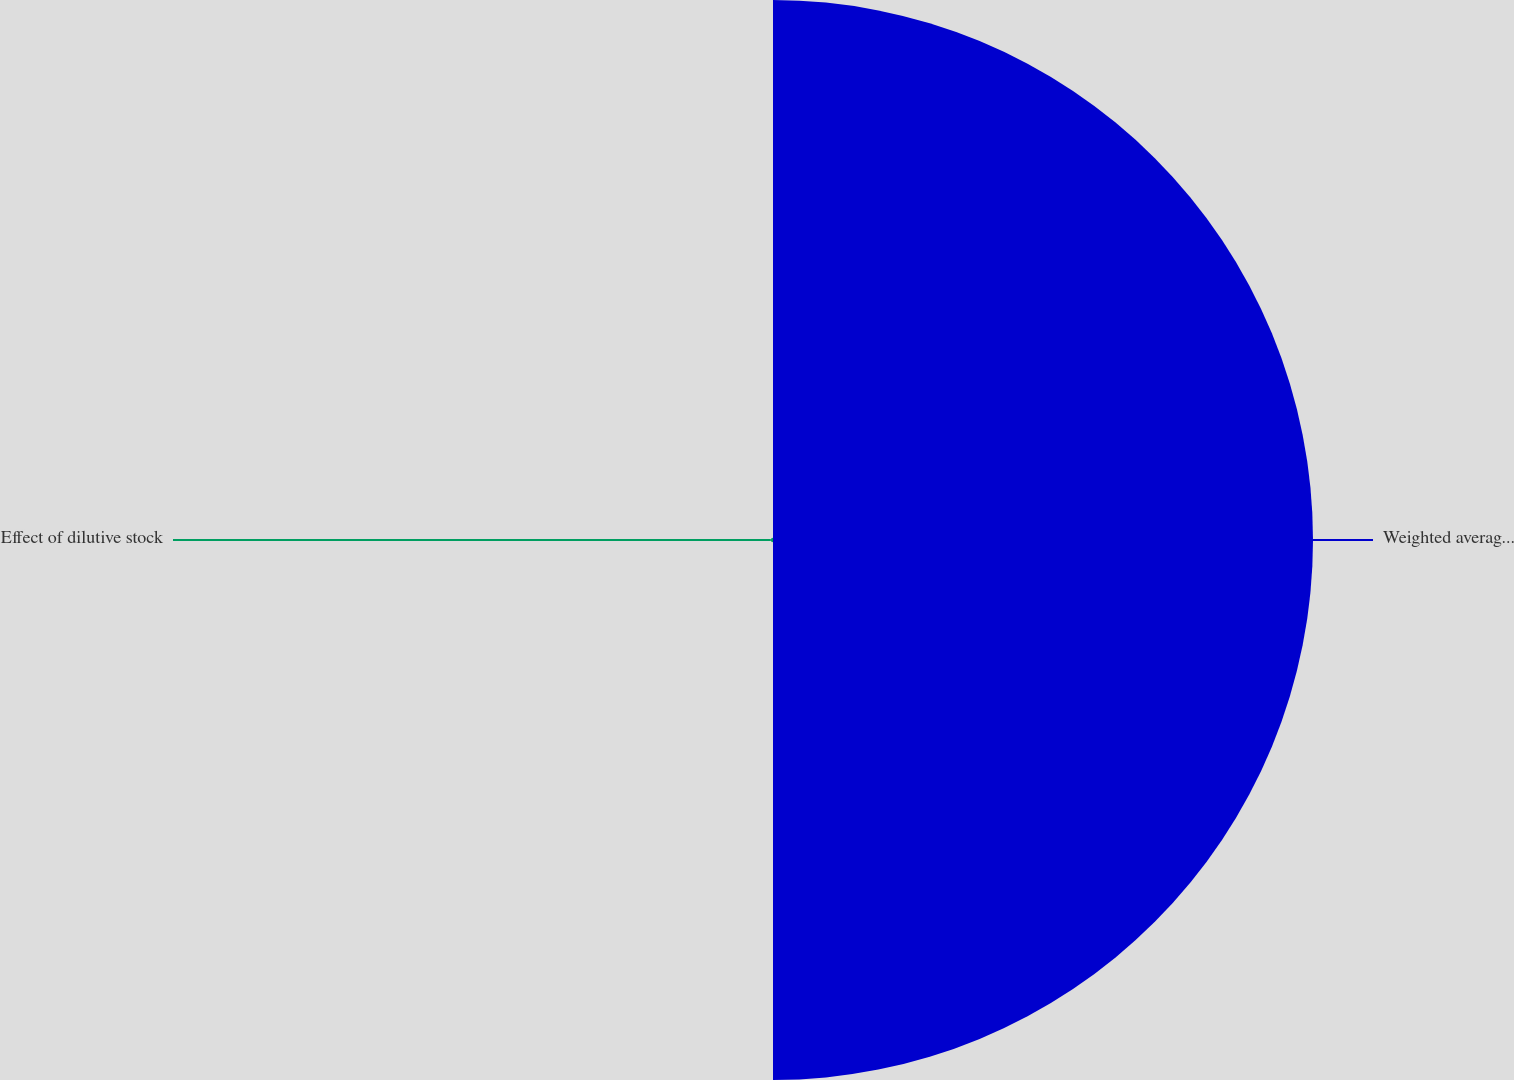Convert chart to OTSL. <chart><loc_0><loc_0><loc_500><loc_500><pie_chart><fcel>Weighted average shares<fcel>Effect of dilutive stock<nl><fcel>99.6%<fcel>0.4%<nl></chart> 